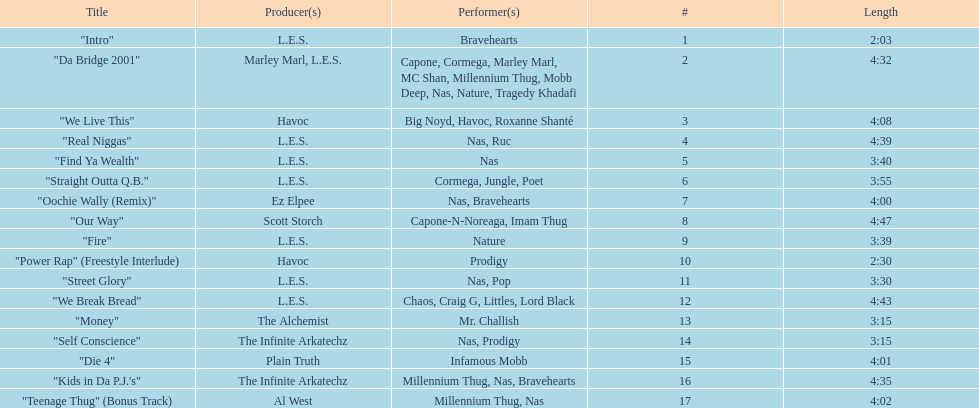Which is longer, fire or die 4? "Die 4". 